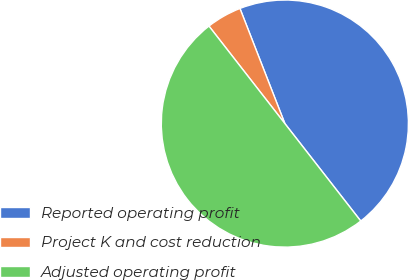Convert chart to OTSL. <chart><loc_0><loc_0><loc_500><loc_500><pie_chart><fcel>Reported operating profit<fcel>Project K and cost reduction<fcel>Adjusted operating profit<nl><fcel>45.39%<fcel>4.61%<fcel>50.0%<nl></chart> 